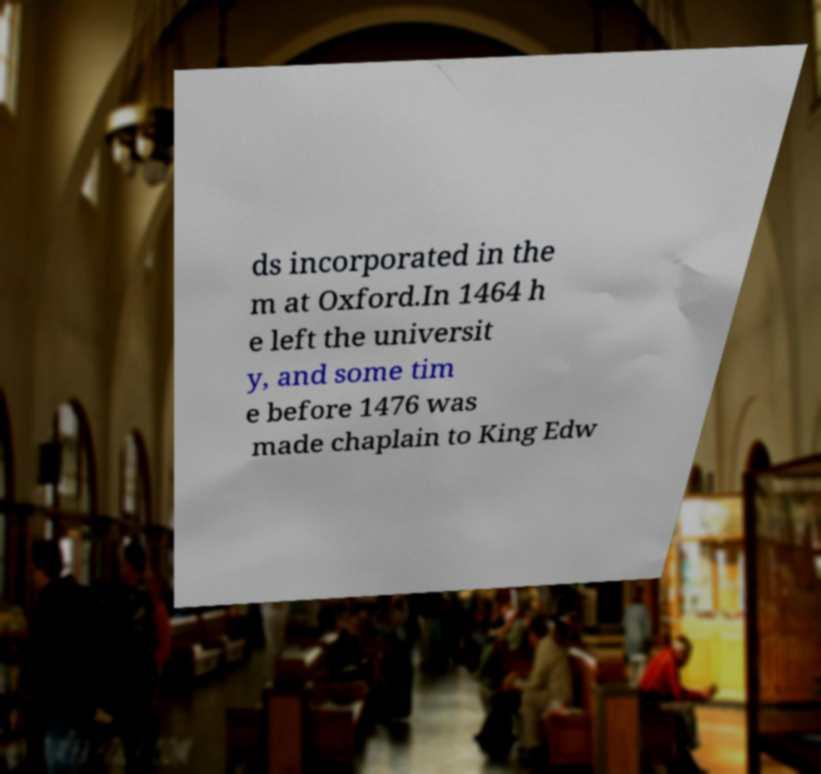Please identify and transcribe the text found in this image. ds incorporated in the m at Oxford.In 1464 h e left the universit y, and some tim e before 1476 was made chaplain to King Edw 